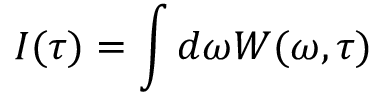<formula> <loc_0><loc_0><loc_500><loc_500>I ( \tau ) = \int d \omega W ( \omega , \tau )</formula> 